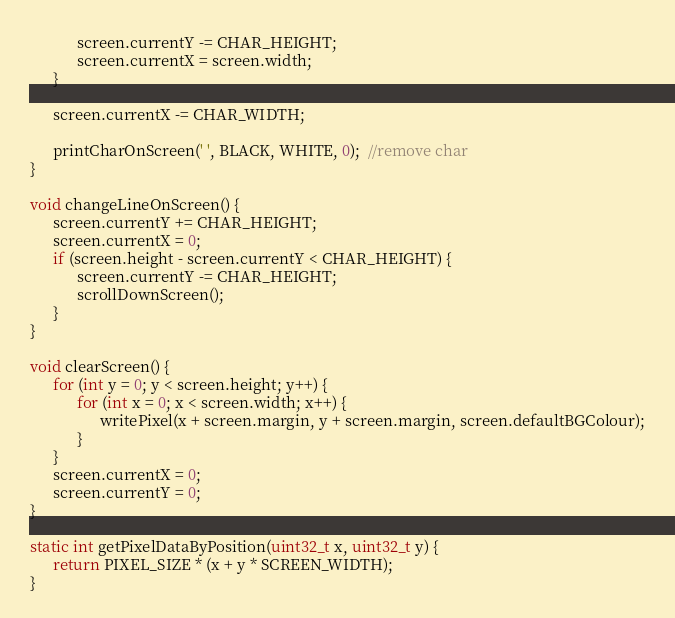<code> <loc_0><loc_0><loc_500><loc_500><_C_>            screen.currentY -= CHAR_HEIGHT;
            screen.currentX = screen.width;
      }

      screen.currentX -= CHAR_WIDTH;

      printCharOnScreen(' ', BLACK, WHITE, 0);  //remove char
}

void changeLineOnScreen() {
      screen.currentY += CHAR_HEIGHT;
      screen.currentX = 0;
      if (screen.height - screen.currentY < CHAR_HEIGHT) {
            screen.currentY -= CHAR_HEIGHT;
            scrollDownScreen();
      }
}

void clearScreen() {
      for (int y = 0; y < screen.height; y++) {
            for (int x = 0; x < screen.width; x++) {
                  writePixel(x + screen.margin, y + screen.margin, screen.defaultBGColour);
            }
      }
      screen.currentX = 0;
      screen.currentY = 0;
}

static int getPixelDataByPosition(uint32_t x, uint32_t y) {
      return PIXEL_SIZE * (x + y * SCREEN_WIDTH);
}
</code> 